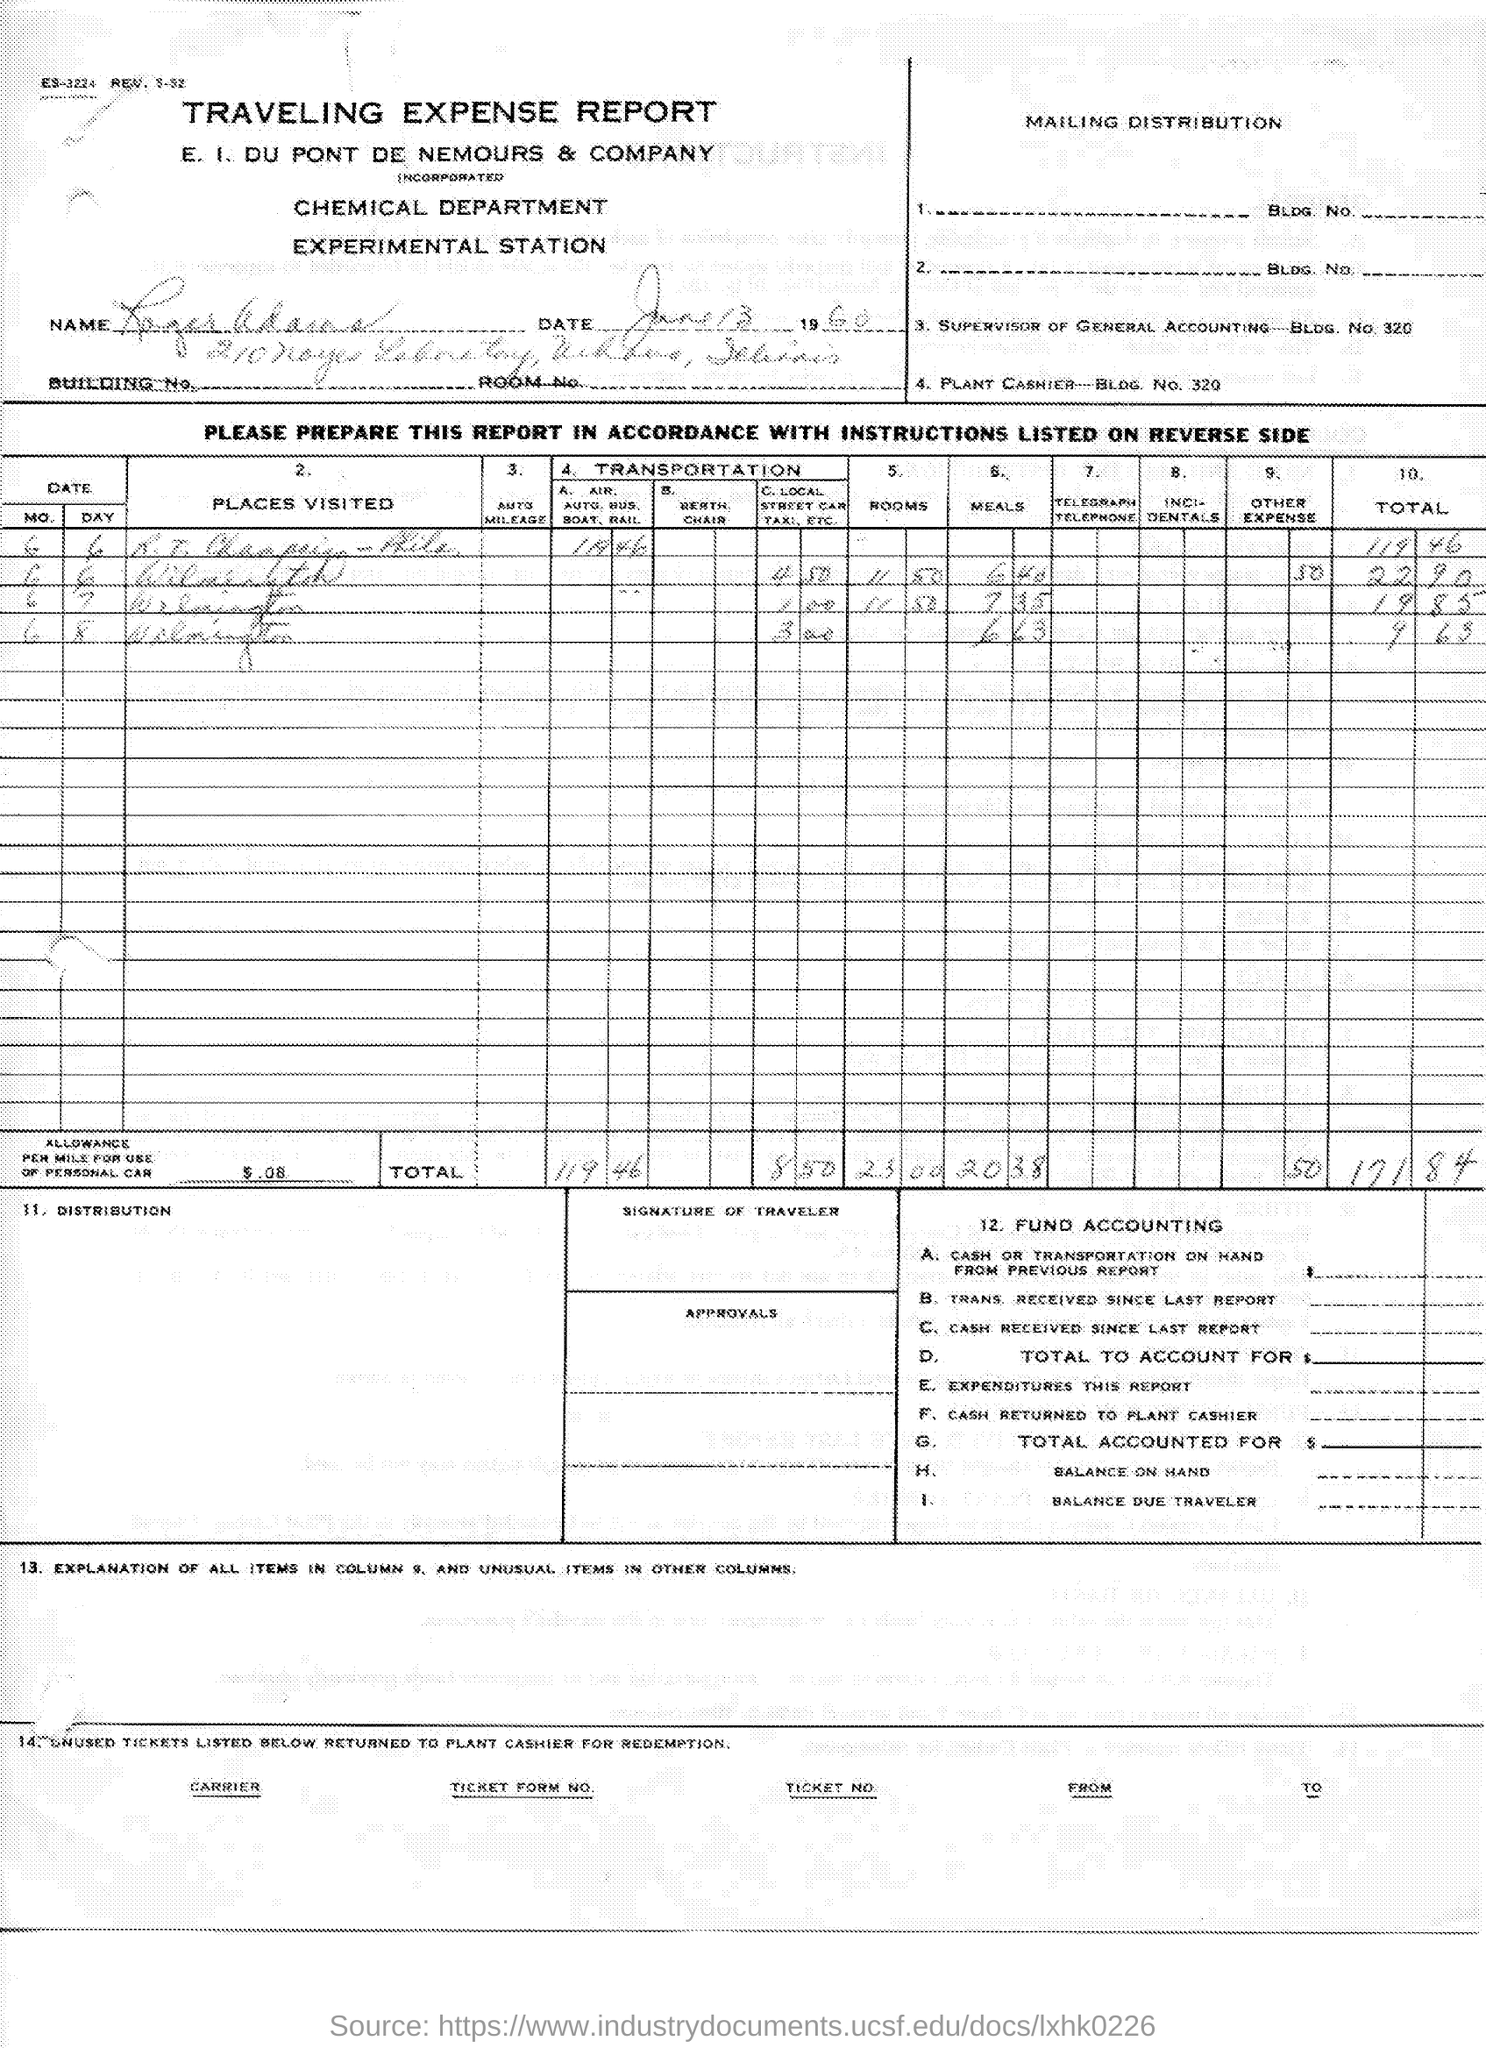Point out several critical features in this image. The company named E. I. du Pont de Nemours & Company is mentioned. This is a declaration that the document in question is a "Traveling Expense Report. The chemical department is involved. 